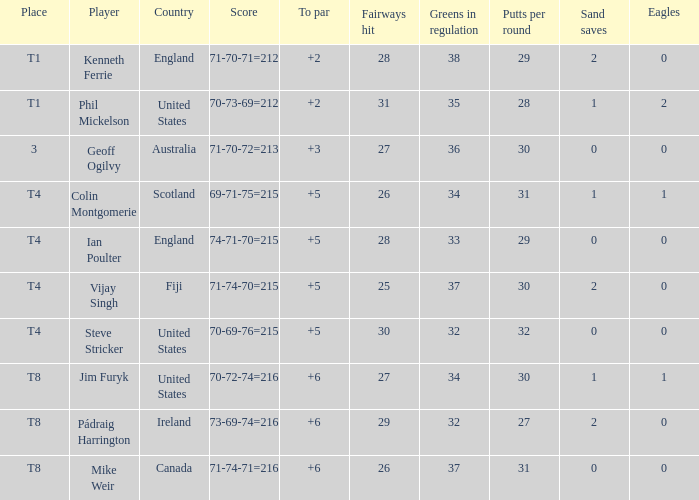What score to par did Mike Weir have? 6.0. Could you parse the entire table? {'header': ['Place', 'Player', 'Country', 'Score', 'To par', 'Fairways hit', 'Greens in regulation', 'Putts per round', 'Sand saves', 'Eagles'], 'rows': [['T1', 'Kenneth Ferrie', 'England', '71-70-71=212', '+2', '28', '38', '29', '2', '0'], ['T1', 'Phil Mickelson', 'United States', '70-73-69=212', '+2', '31', '35', '28', '1', '2'], ['3', 'Geoff Ogilvy', 'Australia', '71-70-72=213', '+3', '27', '36', '30', '0', '0'], ['T4', 'Colin Montgomerie', 'Scotland', '69-71-75=215', '+5', '26', '34', '31', '1', '1'], ['T4', 'Ian Poulter', 'England', '74-71-70=215', '+5', '28', '33', '29', '0', '0'], ['T4', 'Vijay Singh', 'Fiji', '71-74-70=215', '+5', '25', '37', '30', '2', '0'], ['T4', 'Steve Stricker', 'United States', '70-69-76=215', '+5', '30', '32', '32', '0', '0'], ['T8', 'Jim Furyk', 'United States', '70-72-74=216', '+6', '27', '34', '30', '1', '1'], ['T8', 'Pádraig Harrington', 'Ireland', '73-69-74=216', '+6', '29', '32', '27', '2', '0'], ['T8', 'Mike Weir', 'Canada', '71-74-71=216', '+6', '26', '37', '31', '0', '0']]} 